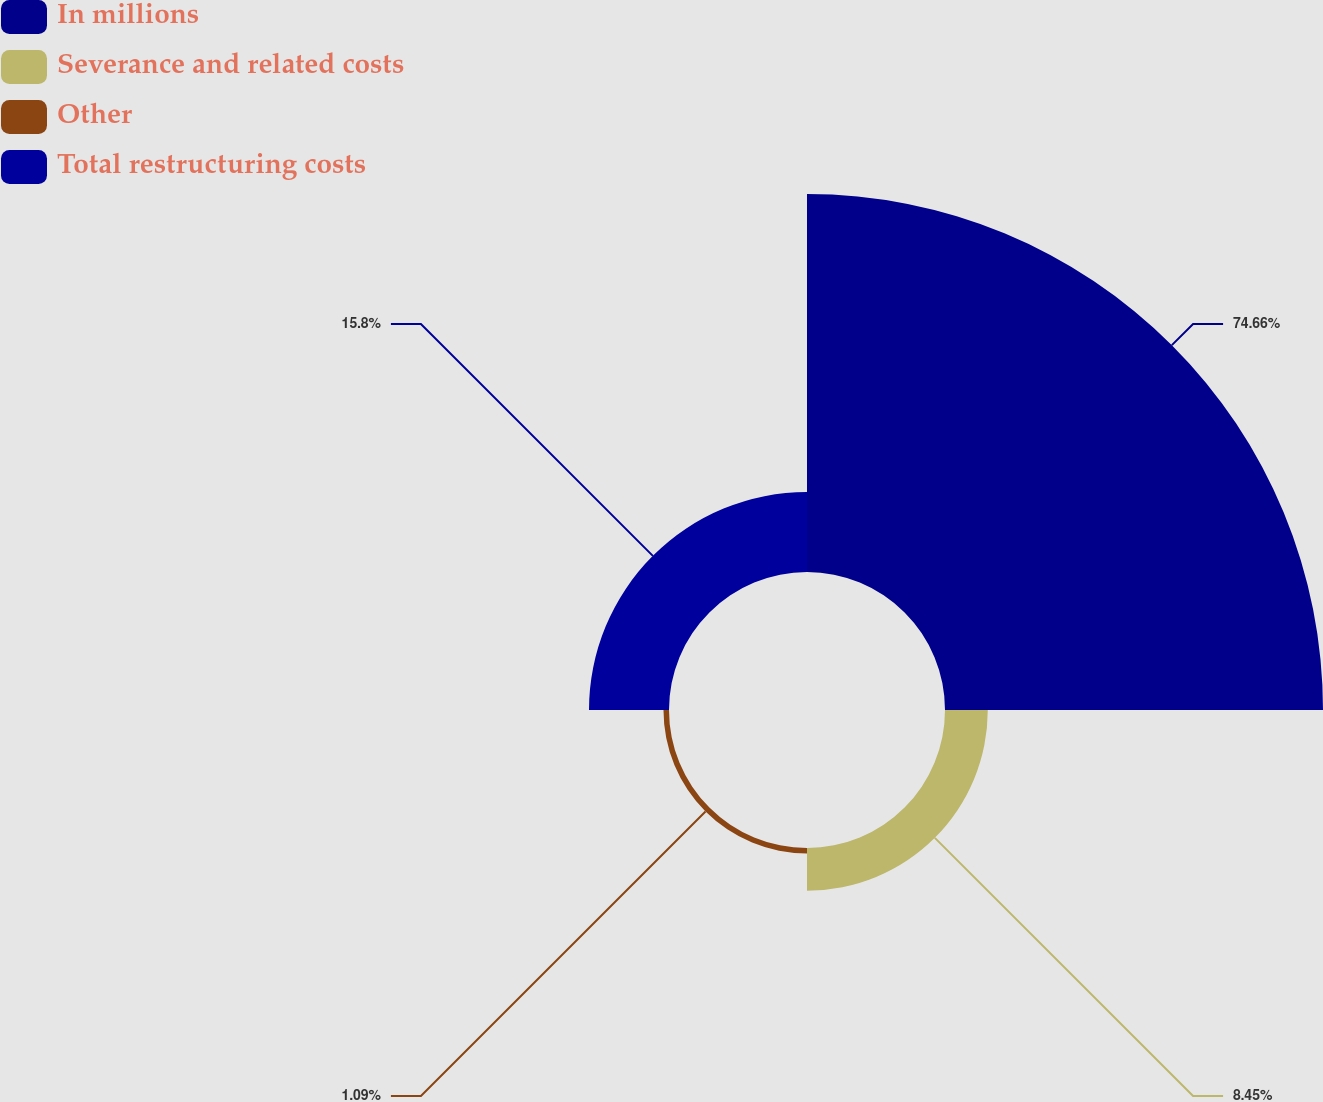Convert chart. <chart><loc_0><loc_0><loc_500><loc_500><pie_chart><fcel>In millions<fcel>Severance and related costs<fcel>Other<fcel>Total restructuring costs<nl><fcel>74.66%<fcel>8.45%<fcel>1.09%<fcel>15.8%<nl></chart> 